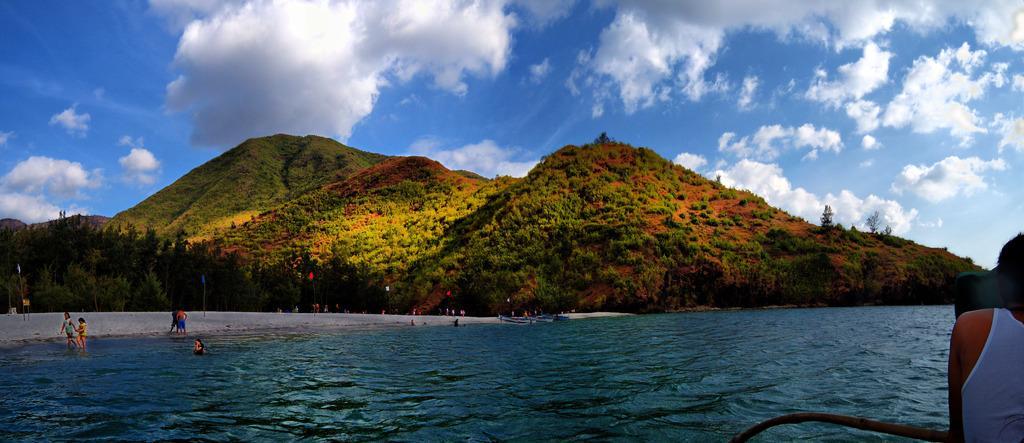Can you describe this image briefly? In this image I can see water, number of trees, number of flags, clouds, the sky and number of people. 